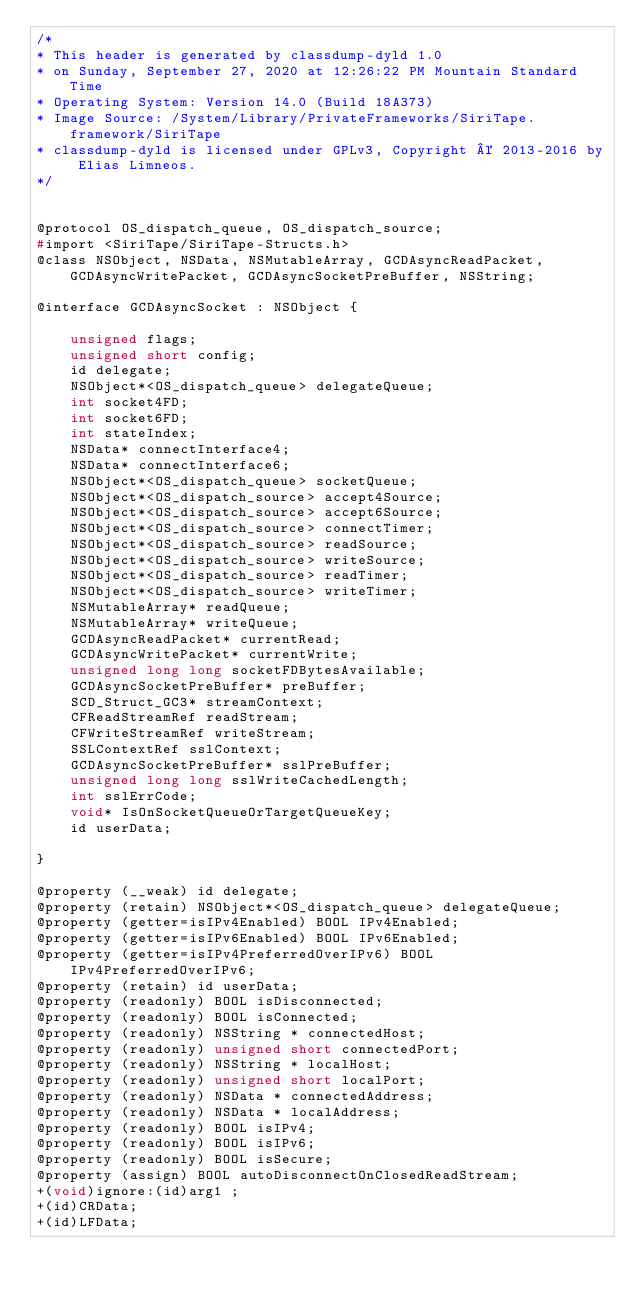<code> <loc_0><loc_0><loc_500><loc_500><_C_>/*
* This header is generated by classdump-dyld 1.0
* on Sunday, September 27, 2020 at 12:26:22 PM Mountain Standard Time
* Operating System: Version 14.0 (Build 18A373)
* Image Source: /System/Library/PrivateFrameworks/SiriTape.framework/SiriTape
* classdump-dyld is licensed under GPLv3, Copyright © 2013-2016 by Elias Limneos.
*/


@protocol OS_dispatch_queue, OS_dispatch_source;
#import <SiriTape/SiriTape-Structs.h>
@class NSObject, NSData, NSMutableArray, GCDAsyncReadPacket, GCDAsyncWritePacket, GCDAsyncSocketPreBuffer, NSString;

@interface GCDAsyncSocket : NSObject {

	unsigned flags;
	unsigned short config;
	id delegate;
	NSObject*<OS_dispatch_queue> delegateQueue;
	int socket4FD;
	int socket6FD;
	int stateIndex;
	NSData* connectInterface4;
	NSData* connectInterface6;
	NSObject*<OS_dispatch_queue> socketQueue;
	NSObject*<OS_dispatch_source> accept4Source;
	NSObject*<OS_dispatch_source> accept6Source;
	NSObject*<OS_dispatch_source> connectTimer;
	NSObject*<OS_dispatch_source> readSource;
	NSObject*<OS_dispatch_source> writeSource;
	NSObject*<OS_dispatch_source> readTimer;
	NSObject*<OS_dispatch_source> writeTimer;
	NSMutableArray* readQueue;
	NSMutableArray* writeQueue;
	GCDAsyncReadPacket* currentRead;
	GCDAsyncWritePacket* currentWrite;
	unsigned long long socketFDBytesAvailable;
	GCDAsyncSocketPreBuffer* preBuffer;
	SCD_Struct_GC3* streamContext;
	CFReadStreamRef readStream;
	CFWriteStreamRef writeStream;
	SSLContextRef sslContext;
	GCDAsyncSocketPreBuffer* sslPreBuffer;
	unsigned long long sslWriteCachedLength;
	int sslErrCode;
	void* IsOnSocketQueueOrTargetQueueKey;
	id userData;

}

@property (__weak) id delegate; 
@property (retain) NSObject*<OS_dispatch_queue> delegateQueue; 
@property (getter=isIPv4Enabled) BOOL IPv4Enabled; 
@property (getter=isIPv6Enabled) BOOL IPv6Enabled; 
@property (getter=isIPv4PreferredOverIPv6) BOOL IPv4PreferredOverIPv6; 
@property (retain) id userData; 
@property (readonly) BOOL isDisconnected; 
@property (readonly) BOOL isConnected; 
@property (readonly) NSString * connectedHost; 
@property (readonly) unsigned short connectedPort; 
@property (readonly) NSString * localHost; 
@property (readonly) unsigned short localPort; 
@property (readonly) NSData * connectedAddress; 
@property (readonly) NSData * localAddress; 
@property (readonly) BOOL isIPv4; 
@property (readonly) BOOL isIPv6; 
@property (readonly) BOOL isSecure; 
@property (assign) BOOL autoDisconnectOnClosedReadStream; 
+(void)ignore:(id)arg1 ;
+(id)CRData;
+(id)LFData;</code> 